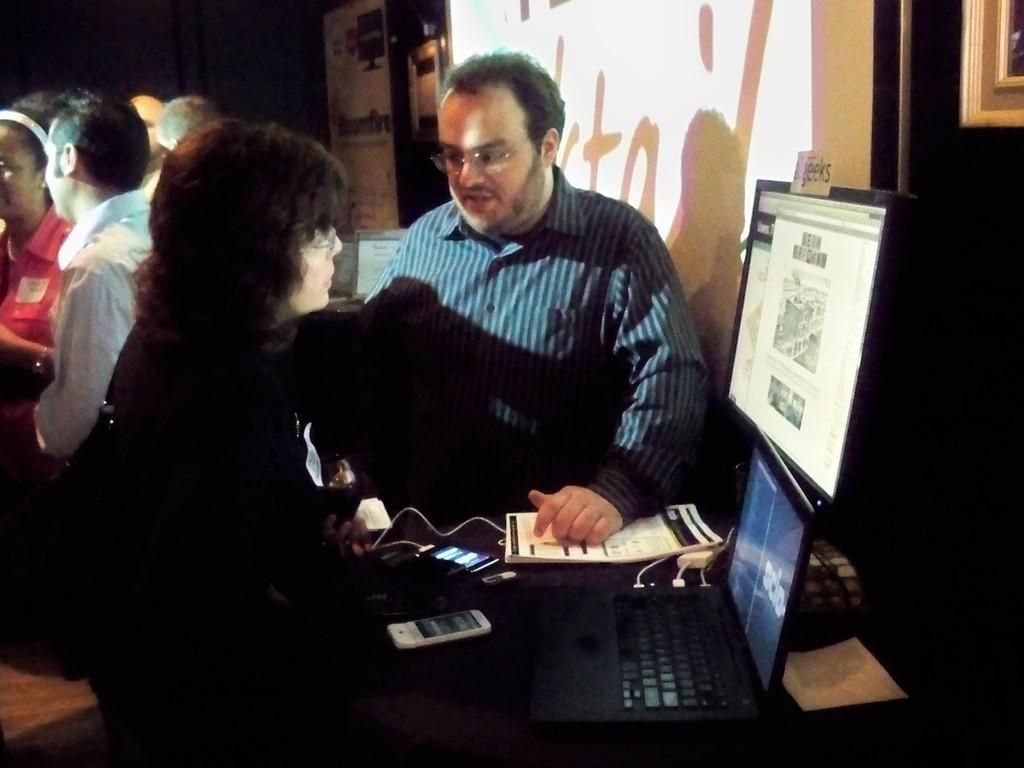Please provide a concise description of this image. As we can see in the image there are few people here and there, wall, photo frame and table. On table there are screens, mobile phone and book. 